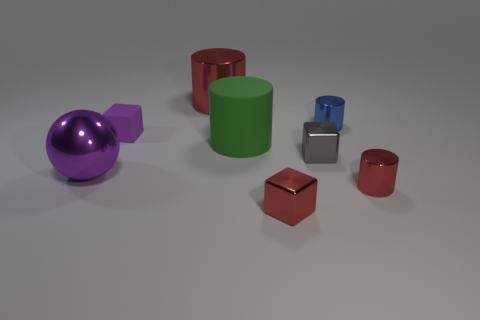Subtract all blue cubes. How many red cylinders are left? 2 Subtract all blue cylinders. How many cylinders are left? 3 Subtract all blue cylinders. How many cylinders are left? 3 Add 1 large purple shiny spheres. How many objects exist? 9 Subtract 1 blocks. How many blocks are left? 2 Subtract all blocks. How many objects are left? 5 Add 2 large red cylinders. How many large red cylinders are left? 3 Add 2 tiny purple rubber objects. How many tiny purple rubber objects exist? 3 Subtract 1 gray cubes. How many objects are left? 7 Subtract all red spheres. Subtract all cyan cylinders. How many spheres are left? 1 